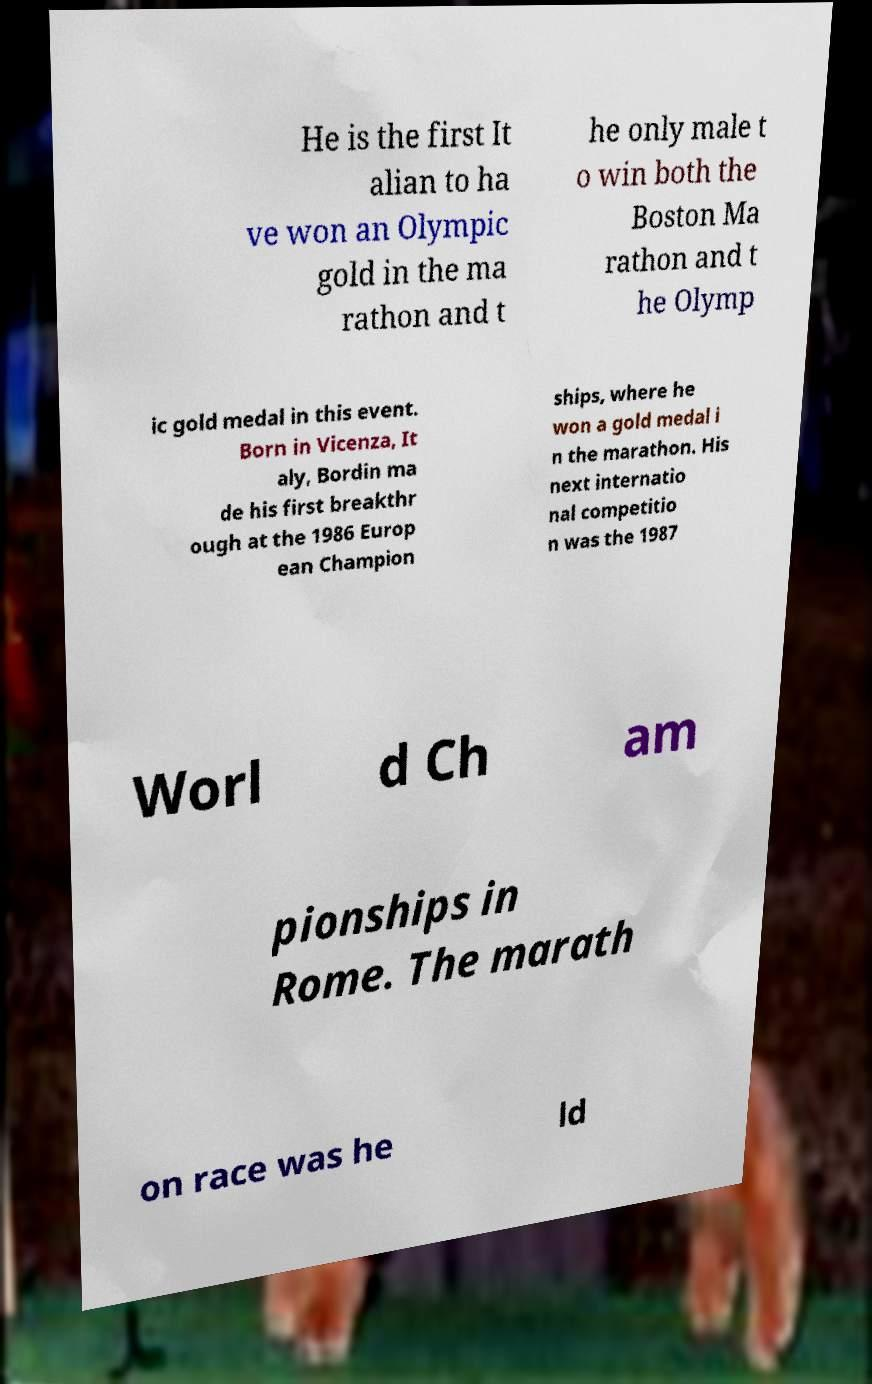Can you accurately transcribe the text from the provided image for me? He is the first It alian to ha ve won an Olympic gold in the ma rathon and t he only male t o win both the Boston Ma rathon and t he Olymp ic gold medal in this event. Born in Vicenza, It aly, Bordin ma de his first breakthr ough at the 1986 Europ ean Champion ships, where he won a gold medal i n the marathon. His next internatio nal competitio n was the 1987 Worl d Ch am pionships in Rome. The marath on race was he ld 